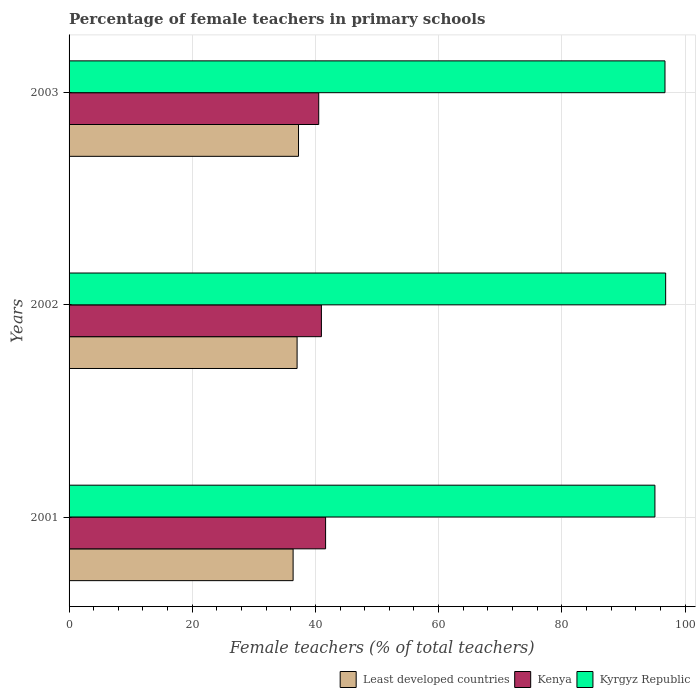How many different coloured bars are there?
Make the answer very short. 3. How many groups of bars are there?
Offer a terse response. 3. What is the percentage of female teachers in Least developed countries in 2001?
Offer a terse response. 36.37. Across all years, what is the maximum percentage of female teachers in Least developed countries?
Offer a terse response. 37.25. Across all years, what is the minimum percentage of female teachers in Kyrgyz Republic?
Provide a short and direct response. 95.12. In which year was the percentage of female teachers in Least developed countries maximum?
Your answer should be compact. 2003. In which year was the percentage of female teachers in Kenya minimum?
Give a very brief answer. 2003. What is the total percentage of female teachers in Kyrgyz Republic in the graph?
Provide a short and direct response. 288.73. What is the difference between the percentage of female teachers in Kyrgyz Republic in 2002 and that in 2003?
Offer a terse response. 0.11. What is the difference between the percentage of female teachers in Least developed countries in 2003 and the percentage of female teachers in Kyrgyz Republic in 2002?
Offer a terse response. -59.61. What is the average percentage of female teachers in Least developed countries per year?
Make the answer very short. 36.88. In the year 2003, what is the difference between the percentage of female teachers in Kenya and percentage of female teachers in Least developed countries?
Offer a very short reply. 3.28. What is the ratio of the percentage of female teachers in Kyrgyz Republic in 2001 to that in 2003?
Your answer should be compact. 0.98. Is the difference between the percentage of female teachers in Kenya in 2002 and 2003 greater than the difference between the percentage of female teachers in Least developed countries in 2002 and 2003?
Offer a very short reply. Yes. What is the difference between the highest and the second highest percentage of female teachers in Kenya?
Provide a succinct answer. 0.68. What is the difference between the highest and the lowest percentage of female teachers in Kyrgyz Republic?
Your answer should be compact. 1.74. What does the 1st bar from the top in 2003 represents?
Give a very brief answer. Kyrgyz Republic. What does the 3rd bar from the bottom in 2002 represents?
Your answer should be very brief. Kyrgyz Republic. How many bars are there?
Your answer should be very brief. 9. How many years are there in the graph?
Make the answer very short. 3. Does the graph contain any zero values?
Provide a succinct answer. No. Does the graph contain grids?
Provide a succinct answer. Yes. Where does the legend appear in the graph?
Ensure brevity in your answer.  Bottom right. How many legend labels are there?
Offer a terse response. 3. How are the legend labels stacked?
Make the answer very short. Horizontal. What is the title of the graph?
Your answer should be compact. Percentage of female teachers in primary schools. What is the label or title of the X-axis?
Offer a terse response. Female teachers (% of total teachers). What is the Female teachers (% of total teachers) in Least developed countries in 2001?
Keep it short and to the point. 36.37. What is the Female teachers (% of total teachers) in Kenya in 2001?
Your answer should be compact. 41.65. What is the Female teachers (% of total teachers) of Kyrgyz Republic in 2001?
Ensure brevity in your answer.  95.12. What is the Female teachers (% of total teachers) of Least developed countries in 2002?
Provide a short and direct response. 37.02. What is the Female teachers (% of total teachers) of Kenya in 2002?
Your answer should be very brief. 40.97. What is the Female teachers (% of total teachers) in Kyrgyz Republic in 2002?
Provide a short and direct response. 96.86. What is the Female teachers (% of total teachers) of Least developed countries in 2003?
Make the answer very short. 37.25. What is the Female teachers (% of total teachers) in Kenya in 2003?
Provide a short and direct response. 40.53. What is the Female teachers (% of total teachers) of Kyrgyz Republic in 2003?
Give a very brief answer. 96.75. Across all years, what is the maximum Female teachers (% of total teachers) of Least developed countries?
Offer a terse response. 37.25. Across all years, what is the maximum Female teachers (% of total teachers) of Kenya?
Your response must be concise. 41.65. Across all years, what is the maximum Female teachers (% of total teachers) in Kyrgyz Republic?
Offer a terse response. 96.86. Across all years, what is the minimum Female teachers (% of total teachers) in Least developed countries?
Your answer should be compact. 36.37. Across all years, what is the minimum Female teachers (% of total teachers) of Kenya?
Give a very brief answer. 40.53. Across all years, what is the minimum Female teachers (% of total teachers) in Kyrgyz Republic?
Give a very brief answer. 95.12. What is the total Female teachers (% of total teachers) of Least developed countries in the graph?
Offer a terse response. 110.65. What is the total Female teachers (% of total teachers) of Kenya in the graph?
Offer a very short reply. 123.15. What is the total Female teachers (% of total teachers) of Kyrgyz Republic in the graph?
Offer a very short reply. 288.73. What is the difference between the Female teachers (% of total teachers) of Least developed countries in 2001 and that in 2002?
Ensure brevity in your answer.  -0.65. What is the difference between the Female teachers (% of total teachers) in Kenya in 2001 and that in 2002?
Ensure brevity in your answer.  0.68. What is the difference between the Female teachers (% of total teachers) of Kyrgyz Republic in 2001 and that in 2002?
Make the answer very short. -1.74. What is the difference between the Female teachers (% of total teachers) in Least developed countries in 2001 and that in 2003?
Offer a very short reply. -0.88. What is the difference between the Female teachers (% of total teachers) in Kenya in 2001 and that in 2003?
Make the answer very short. 1.11. What is the difference between the Female teachers (% of total teachers) of Kyrgyz Republic in 2001 and that in 2003?
Make the answer very short. -1.63. What is the difference between the Female teachers (% of total teachers) of Least developed countries in 2002 and that in 2003?
Ensure brevity in your answer.  -0.23. What is the difference between the Female teachers (% of total teachers) in Kenya in 2002 and that in 2003?
Make the answer very short. 0.44. What is the difference between the Female teachers (% of total teachers) in Kyrgyz Republic in 2002 and that in 2003?
Offer a very short reply. 0.11. What is the difference between the Female teachers (% of total teachers) in Least developed countries in 2001 and the Female teachers (% of total teachers) in Kenya in 2002?
Provide a short and direct response. -4.59. What is the difference between the Female teachers (% of total teachers) in Least developed countries in 2001 and the Female teachers (% of total teachers) in Kyrgyz Republic in 2002?
Your answer should be compact. -60.49. What is the difference between the Female teachers (% of total teachers) of Kenya in 2001 and the Female teachers (% of total teachers) of Kyrgyz Republic in 2002?
Offer a terse response. -55.21. What is the difference between the Female teachers (% of total teachers) of Least developed countries in 2001 and the Female teachers (% of total teachers) of Kenya in 2003?
Make the answer very short. -4.16. What is the difference between the Female teachers (% of total teachers) of Least developed countries in 2001 and the Female teachers (% of total teachers) of Kyrgyz Republic in 2003?
Your answer should be compact. -60.38. What is the difference between the Female teachers (% of total teachers) of Kenya in 2001 and the Female teachers (% of total teachers) of Kyrgyz Republic in 2003?
Provide a short and direct response. -55.1. What is the difference between the Female teachers (% of total teachers) in Least developed countries in 2002 and the Female teachers (% of total teachers) in Kenya in 2003?
Offer a very short reply. -3.51. What is the difference between the Female teachers (% of total teachers) of Least developed countries in 2002 and the Female teachers (% of total teachers) of Kyrgyz Republic in 2003?
Make the answer very short. -59.73. What is the difference between the Female teachers (% of total teachers) of Kenya in 2002 and the Female teachers (% of total teachers) of Kyrgyz Republic in 2003?
Your response must be concise. -55.78. What is the average Female teachers (% of total teachers) in Least developed countries per year?
Make the answer very short. 36.88. What is the average Female teachers (% of total teachers) of Kenya per year?
Offer a terse response. 41.05. What is the average Female teachers (% of total teachers) in Kyrgyz Republic per year?
Offer a very short reply. 96.24. In the year 2001, what is the difference between the Female teachers (% of total teachers) in Least developed countries and Female teachers (% of total teachers) in Kenya?
Keep it short and to the point. -5.27. In the year 2001, what is the difference between the Female teachers (% of total teachers) in Least developed countries and Female teachers (% of total teachers) in Kyrgyz Republic?
Your response must be concise. -58.74. In the year 2001, what is the difference between the Female teachers (% of total teachers) of Kenya and Female teachers (% of total teachers) of Kyrgyz Republic?
Your response must be concise. -53.47. In the year 2002, what is the difference between the Female teachers (% of total teachers) of Least developed countries and Female teachers (% of total teachers) of Kenya?
Keep it short and to the point. -3.95. In the year 2002, what is the difference between the Female teachers (% of total teachers) in Least developed countries and Female teachers (% of total teachers) in Kyrgyz Republic?
Offer a very short reply. -59.84. In the year 2002, what is the difference between the Female teachers (% of total teachers) of Kenya and Female teachers (% of total teachers) of Kyrgyz Republic?
Provide a succinct answer. -55.89. In the year 2003, what is the difference between the Female teachers (% of total teachers) in Least developed countries and Female teachers (% of total teachers) in Kenya?
Your response must be concise. -3.28. In the year 2003, what is the difference between the Female teachers (% of total teachers) in Least developed countries and Female teachers (% of total teachers) in Kyrgyz Republic?
Ensure brevity in your answer.  -59.5. In the year 2003, what is the difference between the Female teachers (% of total teachers) in Kenya and Female teachers (% of total teachers) in Kyrgyz Republic?
Offer a very short reply. -56.22. What is the ratio of the Female teachers (% of total teachers) of Least developed countries in 2001 to that in 2002?
Make the answer very short. 0.98. What is the ratio of the Female teachers (% of total teachers) of Kenya in 2001 to that in 2002?
Your response must be concise. 1.02. What is the ratio of the Female teachers (% of total teachers) in Least developed countries in 2001 to that in 2003?
Provide a succinct answer. 0.98. What is the ratio of the Female teachers (% of total teachers) of Kenya in 2001 to that in 2003?
Provide a succinct answer. 1.03. What is the ratio of the Female teachers (% of total teachers) of Kyrgyz Republic in 2001 to that in 2003?
Ensure brevity in your answer.  0.98. What is the ratio of the Female teachers (% of total teachers) of Least developed countries in 2002 to that in 2003?
Provide a short and direct response. 0.99. What is the ratio of the Female teachers (% of total teachers) of Kenya in 2002 to that in 2003?
Keep it short and to the point. 1.01. What is the difference between the highest and the second highest Female teachers (% of total teachers) in Least developed countries?
Provide a short and direct response. 0.23. What is the difference between the highest and the second highest Female teachers (% of total teachers) in Kenya?
Offer a very short reply. 0.68. What is the difference between the highest and the second highest Female teachers (% of total teachers) in Kyrgyz Republic?
Your answer should be compact. 0.11. What is the difference between the highest and the lowest Female teachers (% of total teachers) in Least developed countries?
Your response must be concise. 0.88. What is the difference between the highest and the lowest Female teachers (% of total teachers) of Kenya?
Provide a succinct answer. 1.11. What is the difference between the highest and the lowest Female teachers (% of total teachers) in Kyrgyz Republic?
Offer a terse response. 1.74. 